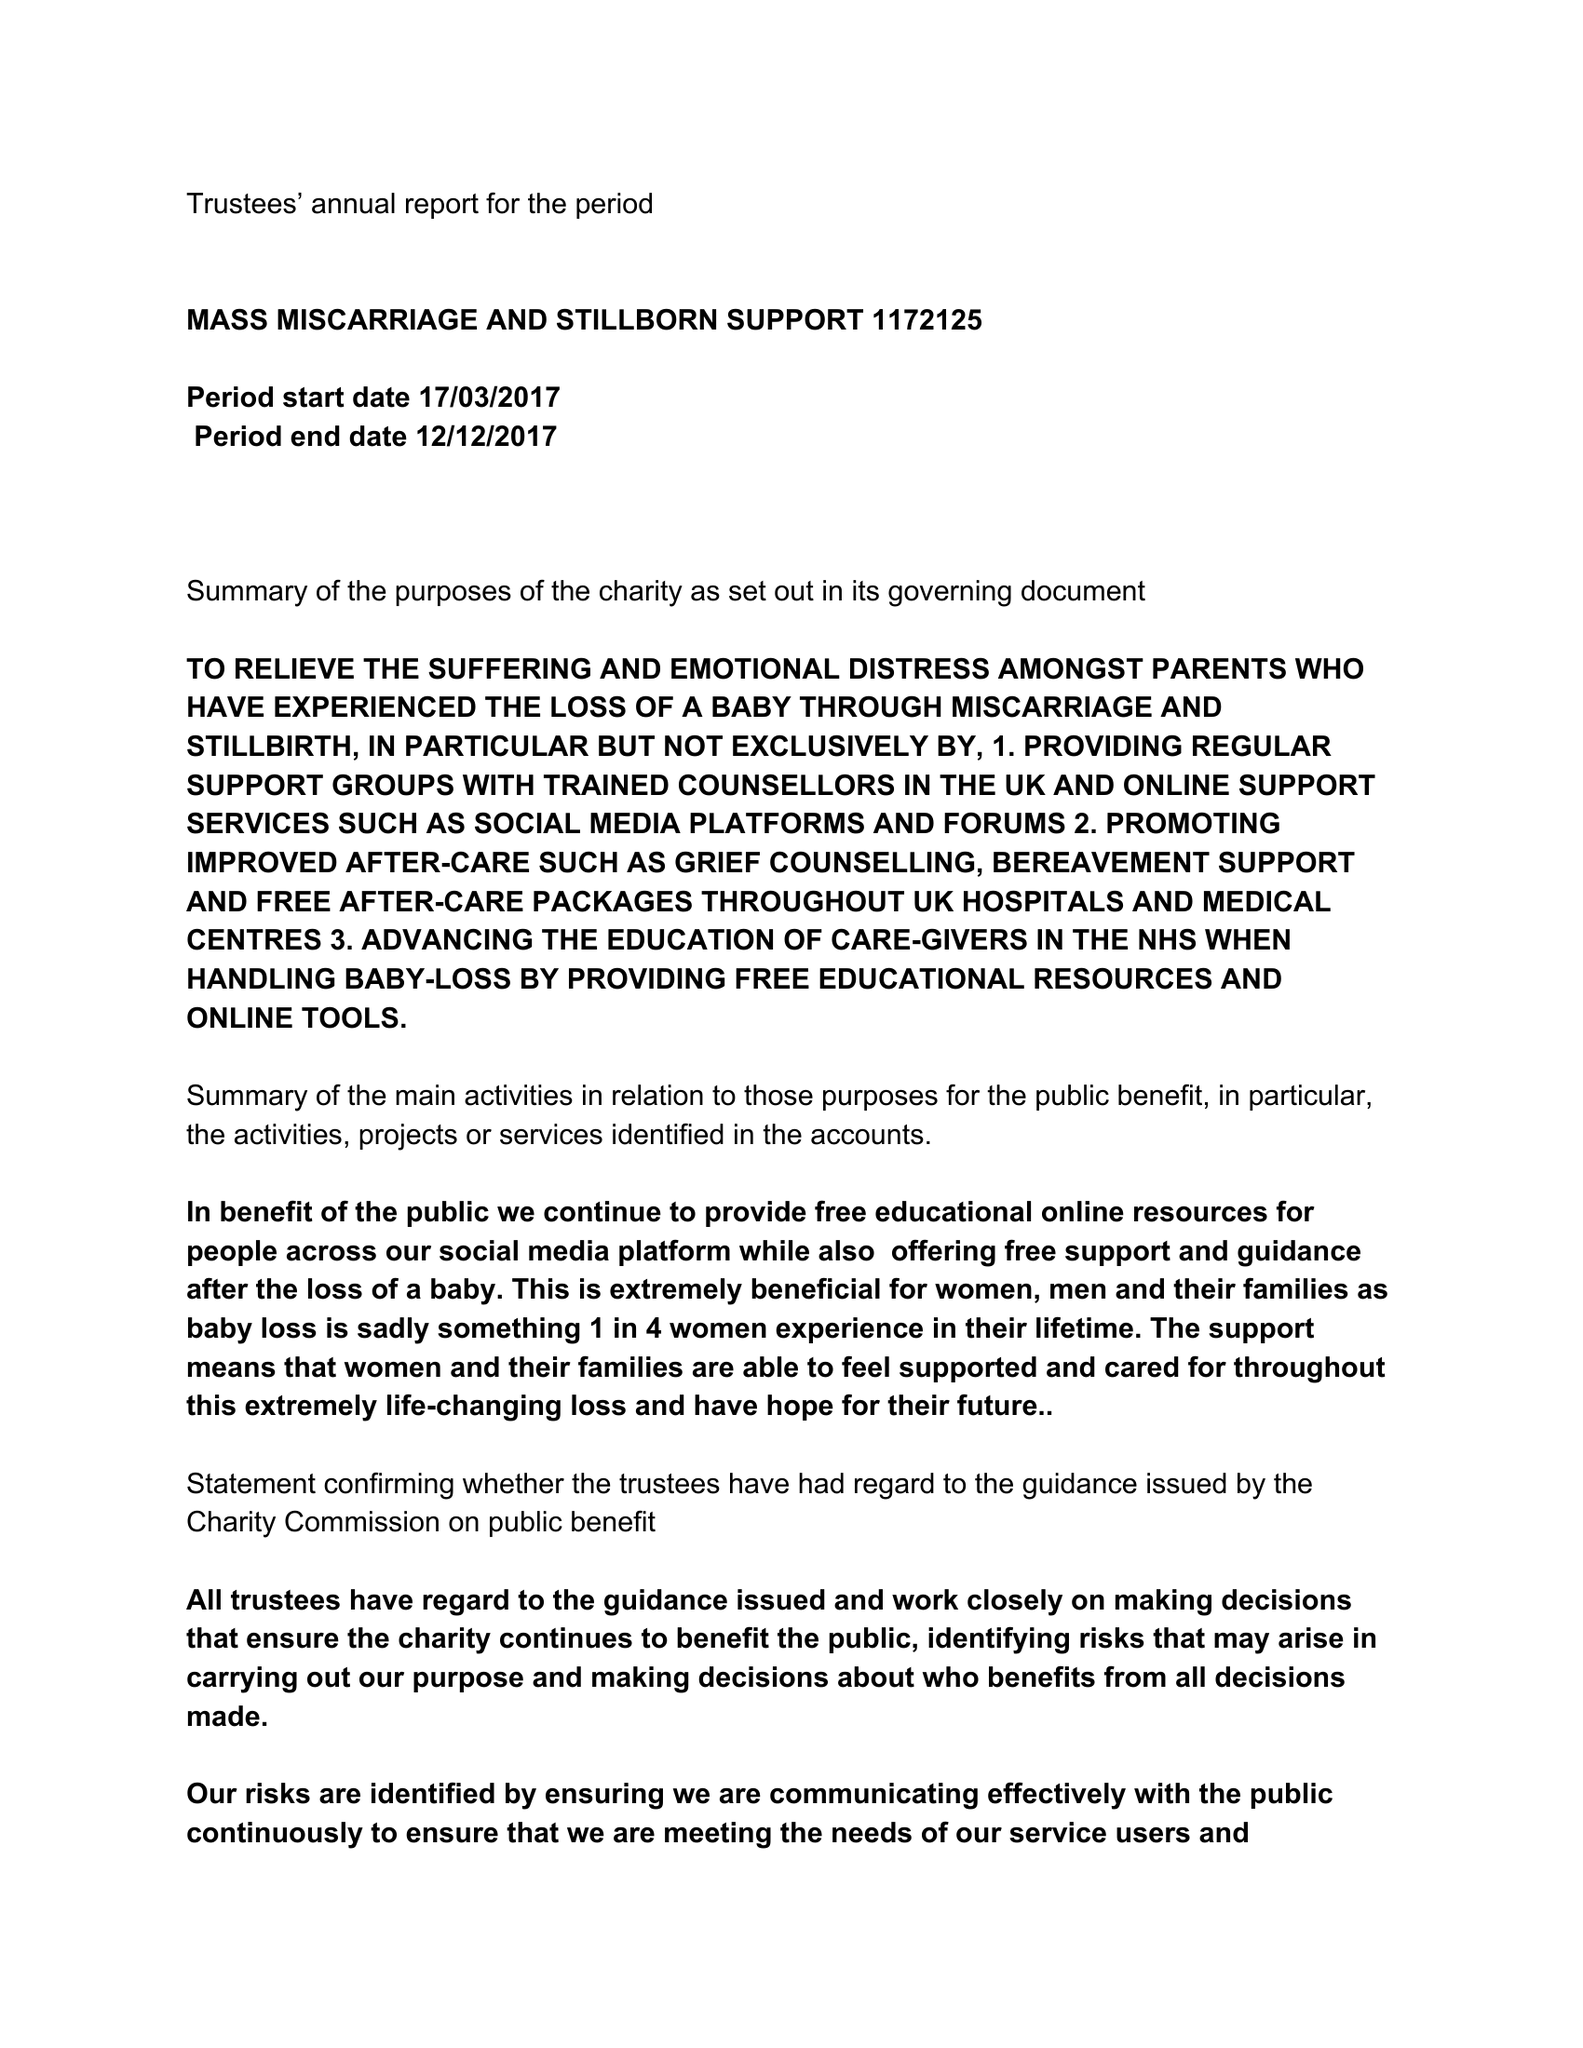What is the value for the charity_name?
Answer the question using a single word or phrase. Mass Miscarriage and Stillborn Support 